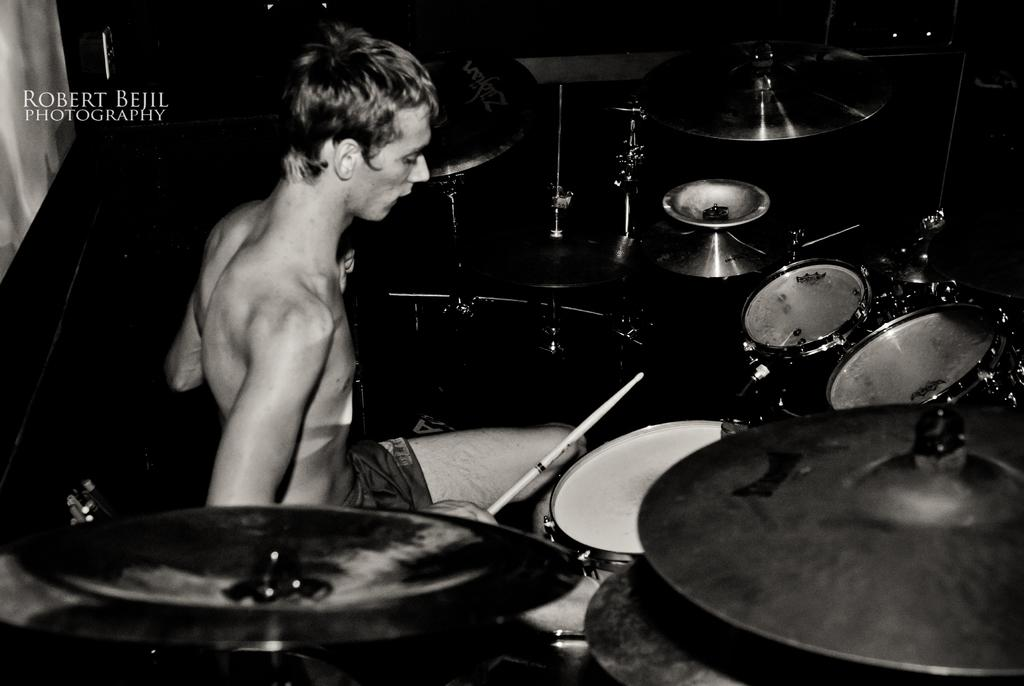Who is the main subject in the image? There is a man in the image. What is the man doing in the image? The man is sitting in front of drums and playing them with sticks. What type of cloud can be seen in the image? There is no cloud present in the image; it features a man playing drums. How many ducks are visible in the image? There are no ducks present in the image. 